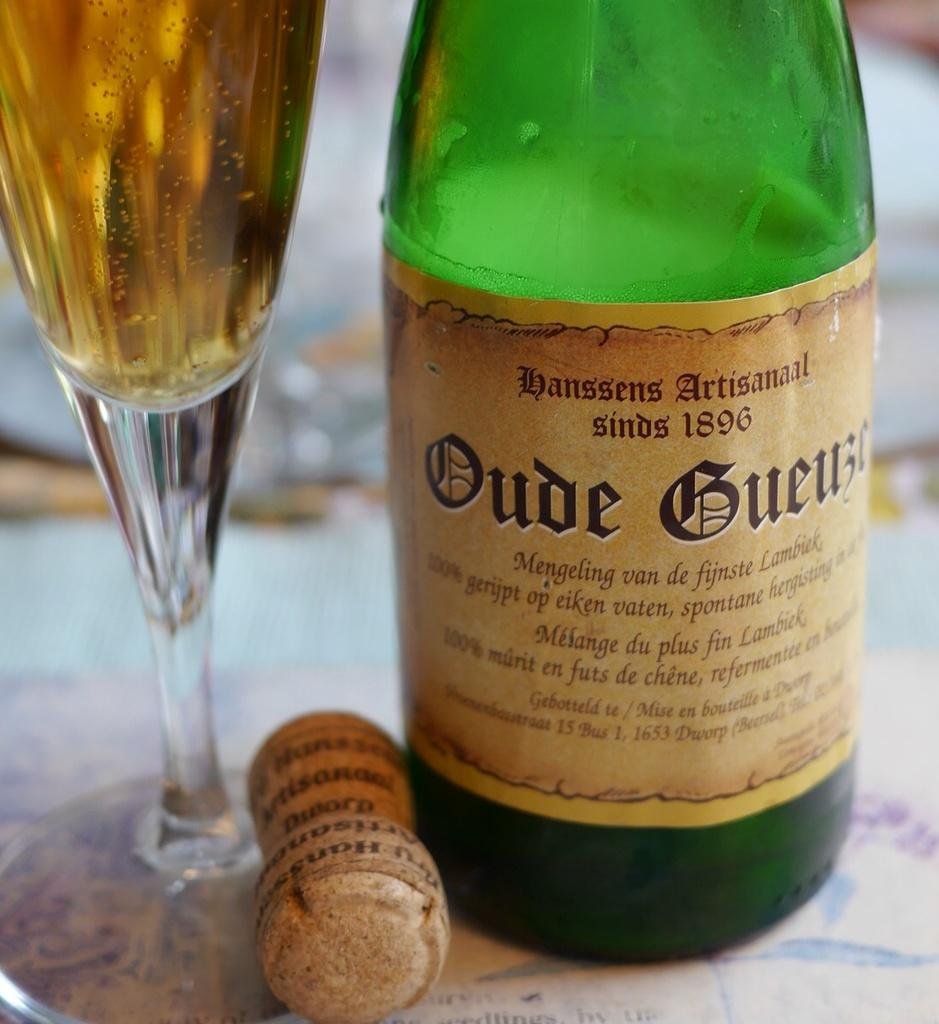What type of container is visible in the image? There is a bottle in the image. What other object related to beverages can be seen in the image? There is a wine glass in the image. Where are the bottle and wine glass located? The bottle and wine glass are placed on a table. Can you describe any other object in the image? There is a stud in the image. What time of day is it in the image, and can you see any baseball players? The time of day is not mentioned in the image, and there are no baseball players visible. 